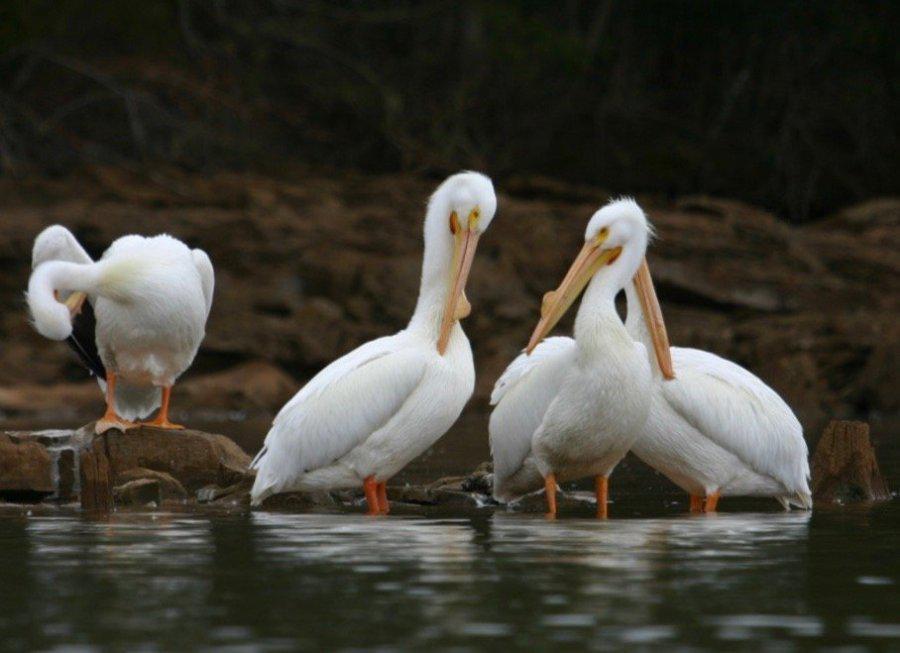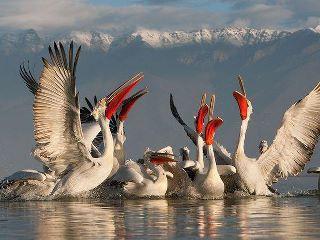The first image is the image on the left, the second image is the image on the right. Analyze the images presented: Is the assertion "All of the birds are in or near the water." valid? Answer yes or no. Yes. 